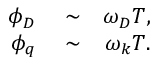<formula> <loc_0><loc_0><loc_500><loc_500>\begin{array} { r l r } { \phi _ { D } } & \sim } & { \omega _ { D } T , } \\ { \phi _ { q } } & \sim } & { \omega _ { k } T . } \end{array}</formula> 